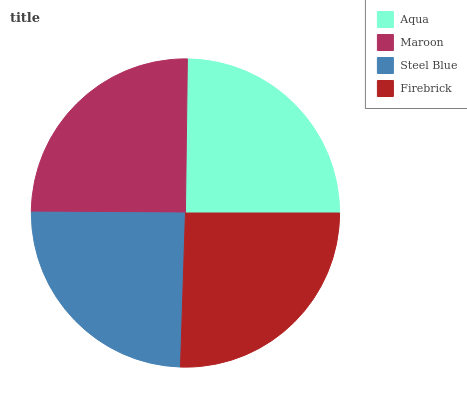Is Steel Blue the minimum?
Answer yes or no. Yes. Is Firebrick the maximum?
Answer yes or no. Yes. Is Maroon the minimum?
Answer yes or no. No. Is Maroon the maximum?
Answer yes or no. No. Is Maroon greater than Aqua?
Answer yes or no. Yes. Is Aqua less than Maroon?
Answer yes or no. Yes. Is Aqua greater than Maroon?
Answer yes or no. No. Is Maroon less than Aqua?
Answer yes or no. No. Is Maroon the high median?
Answer yes or no. Yes. Is Aqua the low median?
Answer yes or no. Yes. Is Aqua the high median?
Answer yes or no. No. Is Maroon the low median?
Answer yes or no. No. 